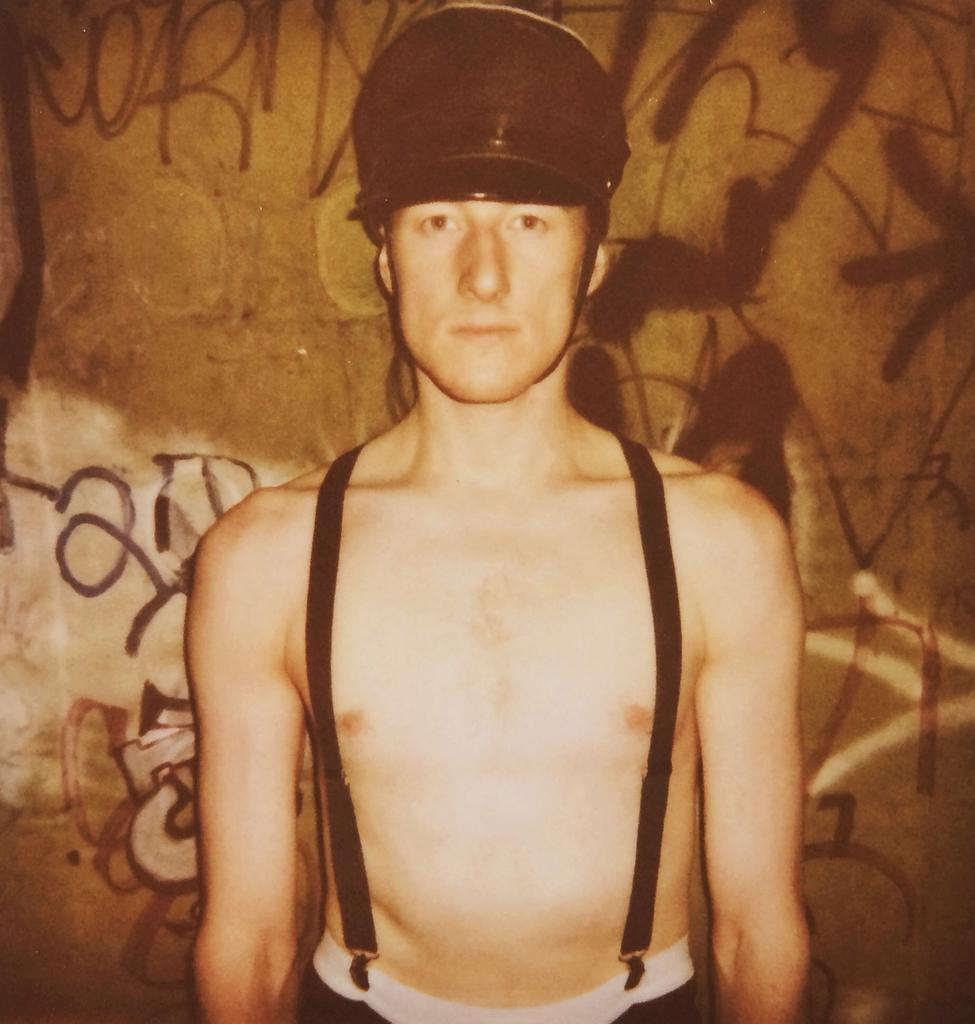Who is present in the image? There is a person in the image. What is the person wearing on their head? The person is wearing a cap. What is the person's posture in the image? The person is standing. What can be seen in the background of the image? There is a wall in the background of the image. What is written or depicted on the wall? The wall has text on it. How many boys are sitting on the cushion in the image? There is no cushion or boys present in the image. 